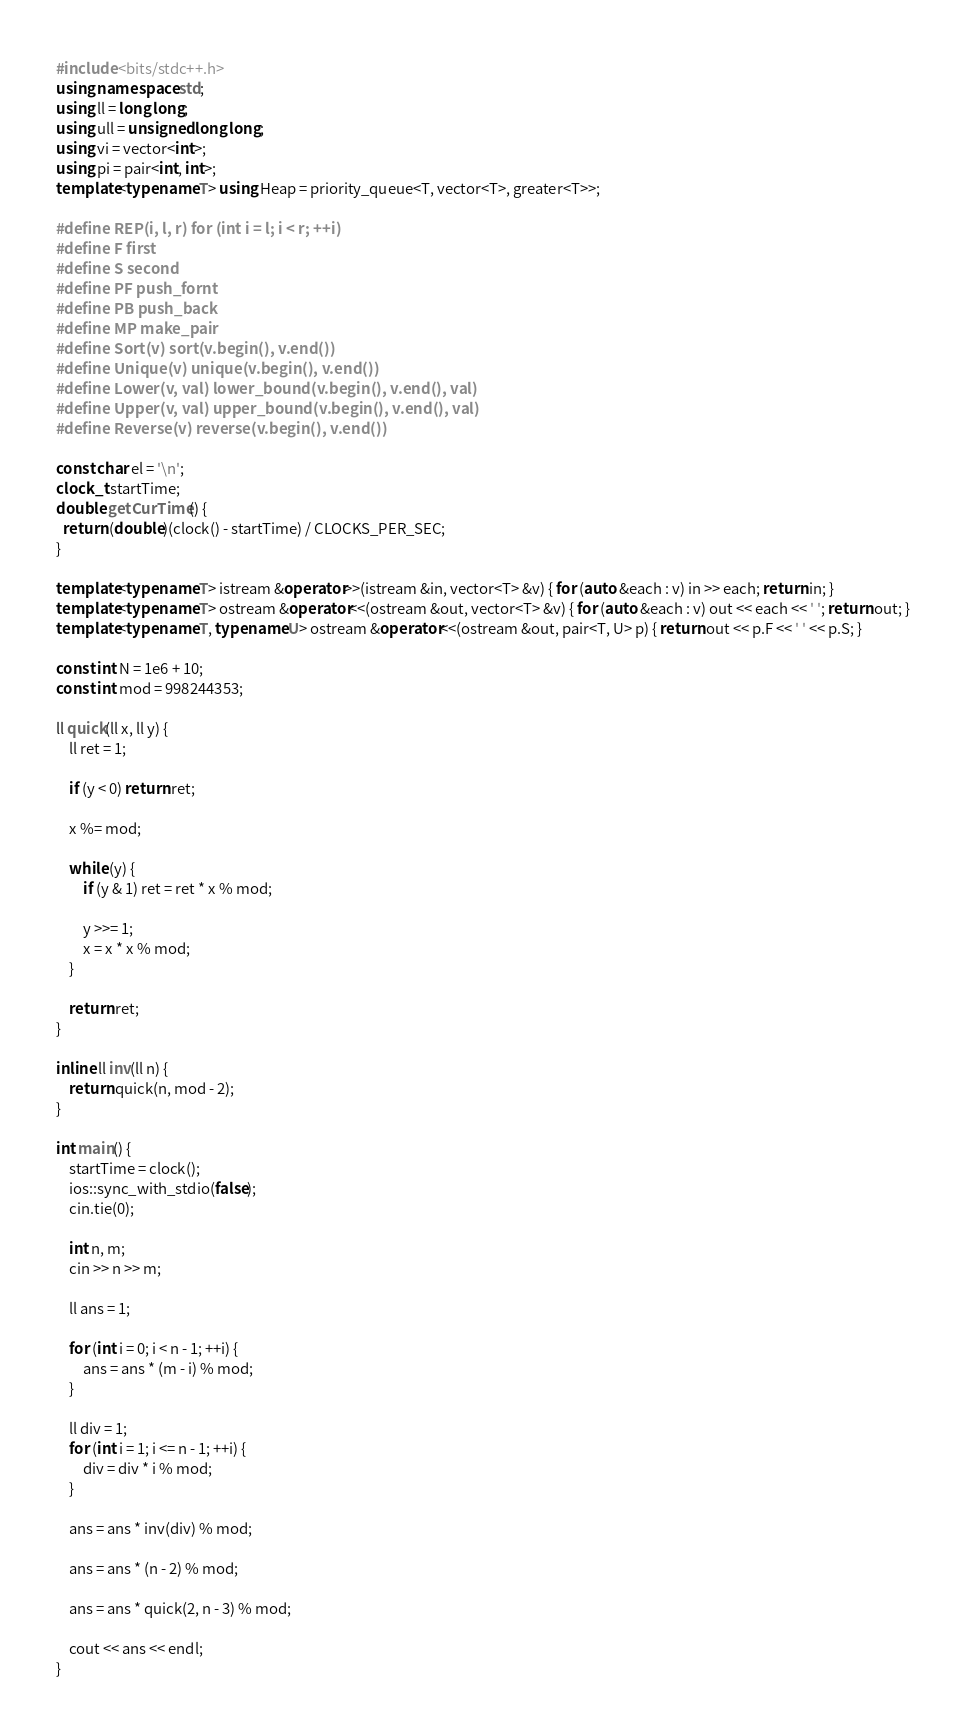<code> <loc_0><loc_0><loc_500><loc_500><_C++_>#include <bits/stdc++.h>
using namespace std;
using ll = long long;
using ull = unsigned long long;
using vi = vector<int>;
using pi = pair<int, int>;
template<typename T> using Heap = priority_queue<T, vector<T>, greater<T>>;

#define REP(i, l, r) for (int i = l; i < r; ++i)
#define F first
#define S second
#define PF push_fornt
#define PB push_back
#define MP make_pair
#define Sort(v) sort(v.begin(), v.end())
#define Unique(v) unique(v.begin(), v.end())
#define Lower(v, val) lower_bound(v.begin(), v.end(), val)
#define Upper(v, val) upper_bound(v.begin(), v.end(), val)
#define Reverse(v) reverse(v.begin(), v.end())

const char el = '\n';
clock_t startTime;
double getCurTime() {
  return (double)(clock() - startTime) / CLOCKS_PER_SEC;
}

template<typename T> istream &operator>>(istream &in, vector<T> &v) { for (auto &each : v) in >> each; return in; }
template<typename T> ostream &operator<<(ostream &out, vector<T> &v) { for (auto &each : v) out << each << ' '; return out; }
template<typename T, typename U> ostream &operator<<(ostream &out, pair<T, U> p) { return out << p.F << ' ' << p.S; }

const int N = 1e6 + 10;
const int mod = 998244353;

ll quick(ll x, ll y) {
    ll ret = 1;

    if (y < 0) return ret;

    x %= mod;

    while (y) {
        if (y & 1) ret = ret * x % mod;

        y >>= 1;
        x = x * x % mod;
    }

    return ret;
}

inline ll inv(ll n) {
    return quick(n, mod - 2);
}

int main() {
    startTime = clock();
    ios::sync_with_stdio(false);
    cin.tie(0);

    int n, m;
    cin >> n >> m;

    ll ans = 1;

    for (int i = 0; i < n - 1; ++i) {
        ans = ans * (m - i) % mod;
    }

    ll div = 1;
    for (int i = 1; i <= n - 1; ++i) {
        div = div * i % mod;
    }

    ans = ans * inv(div) % mod;

    ans = ans * (n - 2) % mod;

    ans = ans * quick(2, n - 3) % mod;

    cout << ans << endl;
}
</code> 